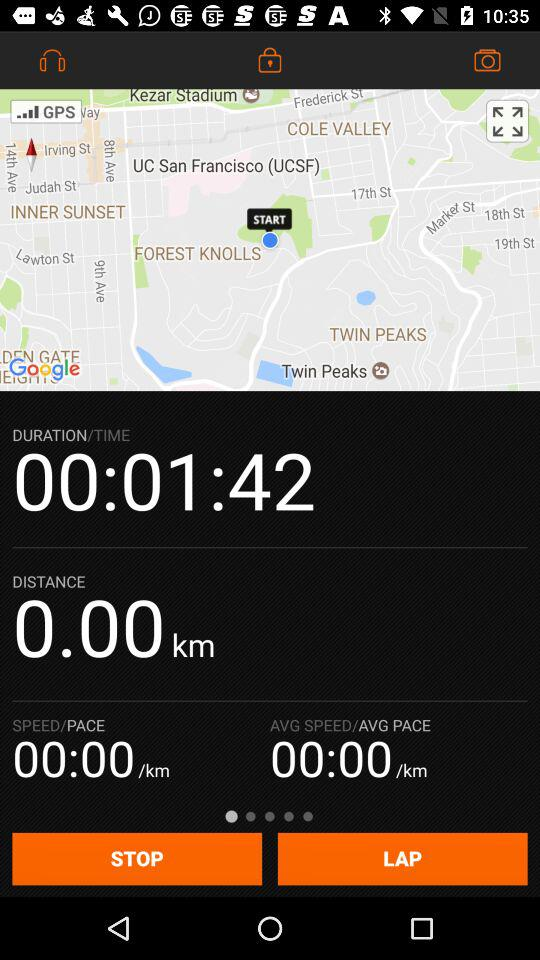What is the unit of distance? The unit of distance is km. 